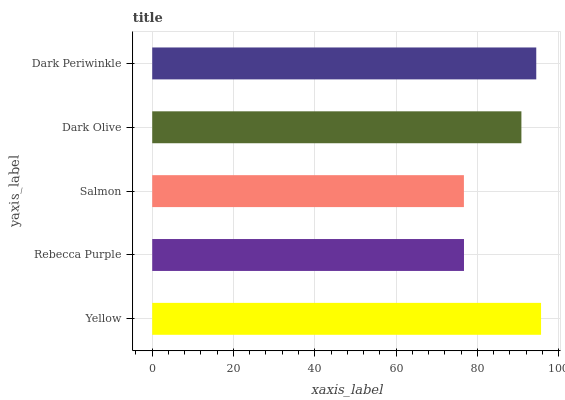Is Salmon the minimum?
Answer yes or no. Yes. Is Yellow the maximum?
Answer yes or no. Yes. Is Rebecca Purple the minimum?
Answer yes or no. No. Is Rebecca Purple the maximum?
Answer yes or no. No. Is Yellow greater than Rebecca Purple?
Answer yes or no. Yes. Is Rebecca Purple less than Yellow?
Answer yes or no. Yes. Is Rebecca Purple greater than Yellow?
Answer yes or no. No. Is Yellow less than Rebecca Purple?
Answer yes or no. No. Is Dark Olive the high median?
Answer yes or no. Yes. Is Dark Olive the low median?
Answer yes or no. Yes. Is Yellow the high median?
Answer yes or no. No. Is Rebecca Purple the low median?
Answer yes or no. No. 